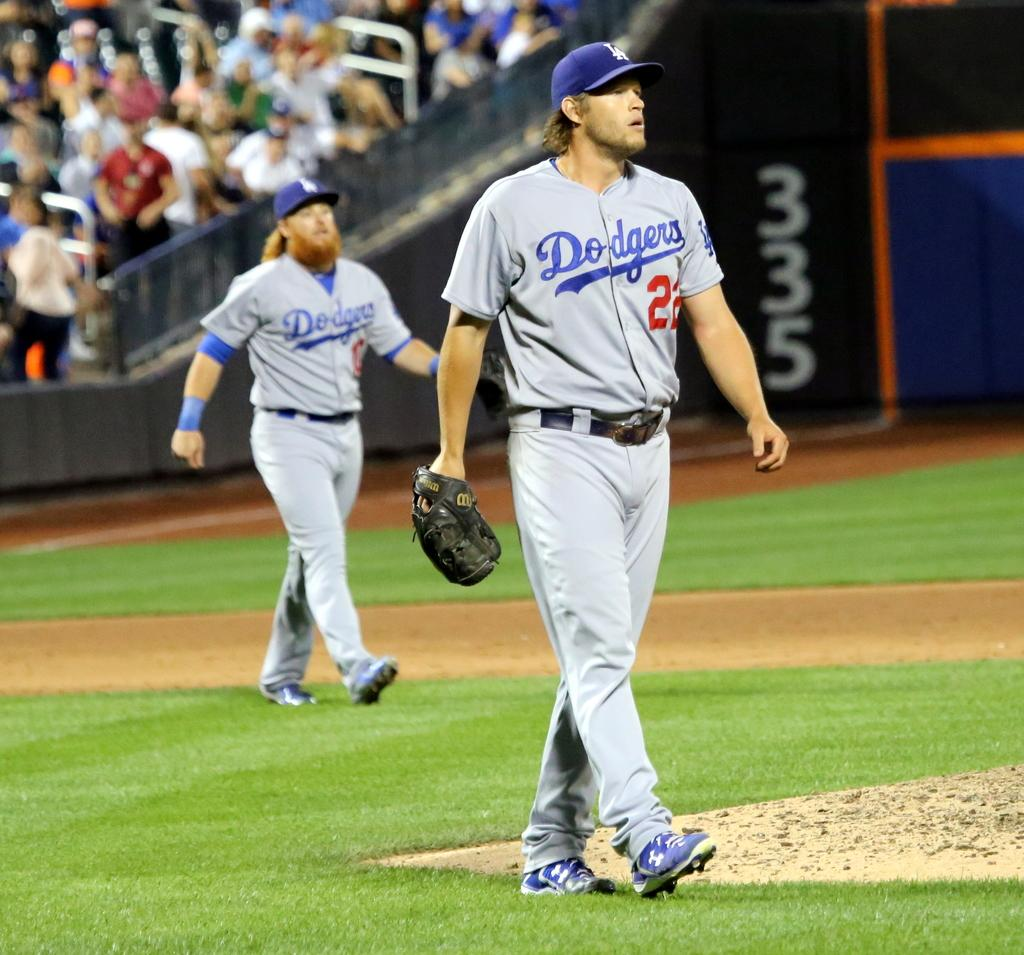Provide a one-sentence caption for the provided image. Two male baseball players for the Dodgers on the field. 